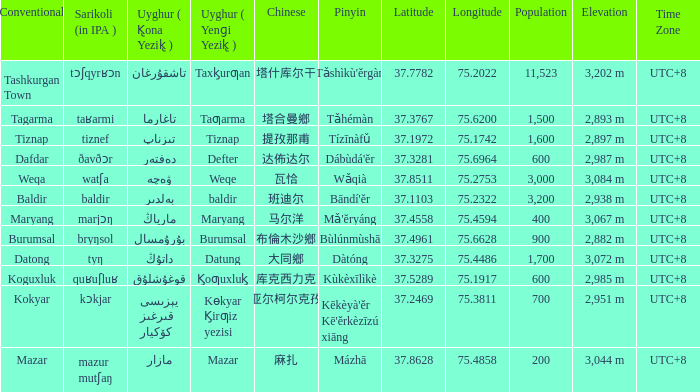Name the uyghur for  瓦恰 ۋەچە. 